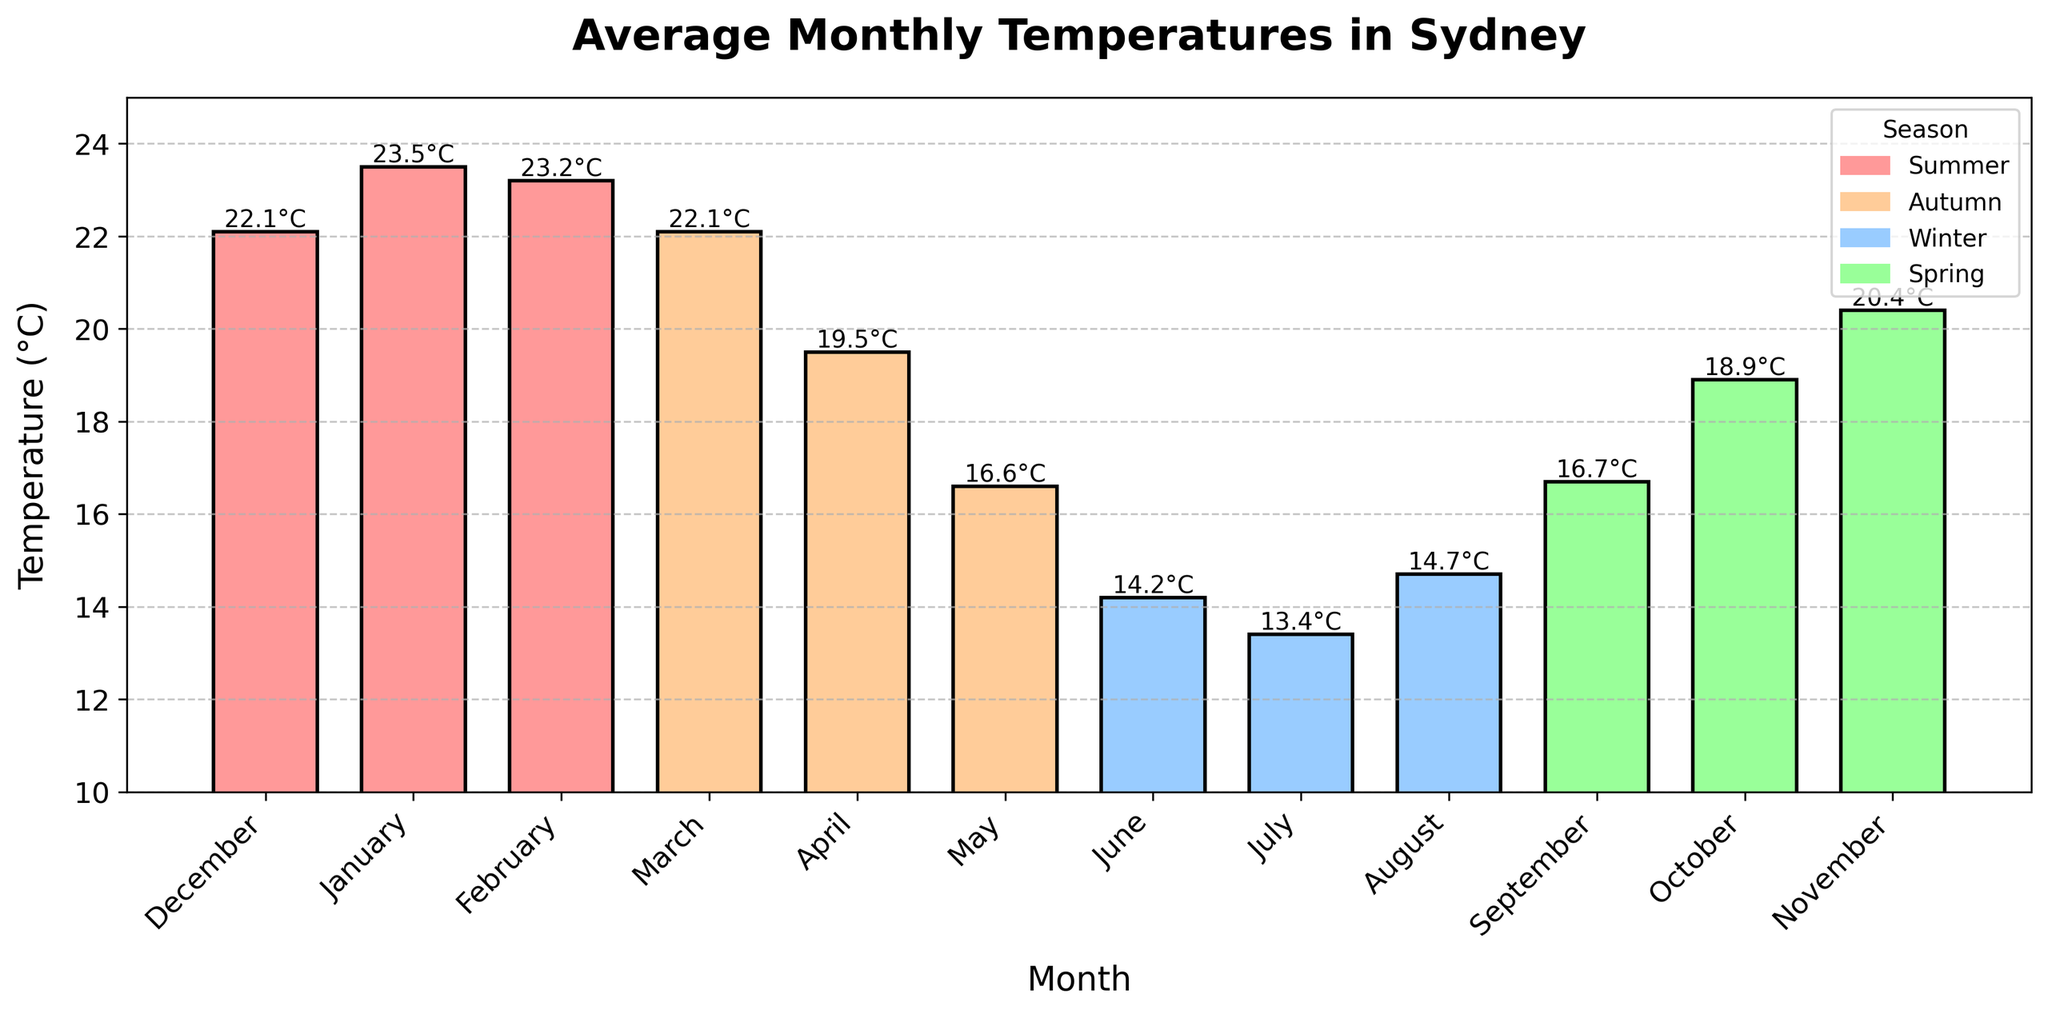What's the warmest month in Sydney? The tallest bar on the chart represents the warmest month. In this case, January with an average temperature of 23.5°C is the tallest bar.
Answer: January Which season has the lowest overall temperatures? The shortest bars represent the lowest temperatures. Winter (June, July, August) has the lowest bars, with temperatures between 13.4°C and 14.7°C.
Answer: Winter What is the average temperature for the entire year? Add the average temperatures for each month and then divide by the number of months (12). The calculation is (22.1 + 23.5 + 23.2 + 22.1 + 19.5 + 16.6 + 14.2 + 13.4 + 14.7 + 16.7 + 18.9 + 20.4) / 12 = 18.4°C.
Answer: 18.4°C How much higher is the average temperature in February compared to June? Subtract the average temperature of June from the average temperature of February. This is 23.2 - 14.2 = 9.0°C.
Answer: 9.0°C Which month has an average temperature closest to 20°C? Look for the bar whose height is closest to 20°C. November has an average temperature of 20.4°C, which is the closest.
Answer: November What is the range of the average temperatures in Spring? Find the difference between the highest and lowest temperatures in Spring. The highest is November (20.4°C) and the lowest is September (16.7°C). The range is 20.4 - 16.7 = 3.7°C.
Answer: 3.7°C How does the average temperature in May compare to September? Compare the heights of the bars for May and September. May is slightly lower with 16.6°C compared to 16.7°C in September.
Answer: May is slightly lower What is the total of the average temperatures for the winter months? Add the average temperatures for June, July, and August. The calculation is 14.2 + 13.4 + 14.7 = 42.3°C.
Answer: 42.3°C Which season has the most consistent temperatures (least variation)? Look at the height differences between the bars for each season. Spring and Winter bars are comparatively closer in height, but Winter varies the least from 13.4°C to 14.7°C.
Answer: Winter 